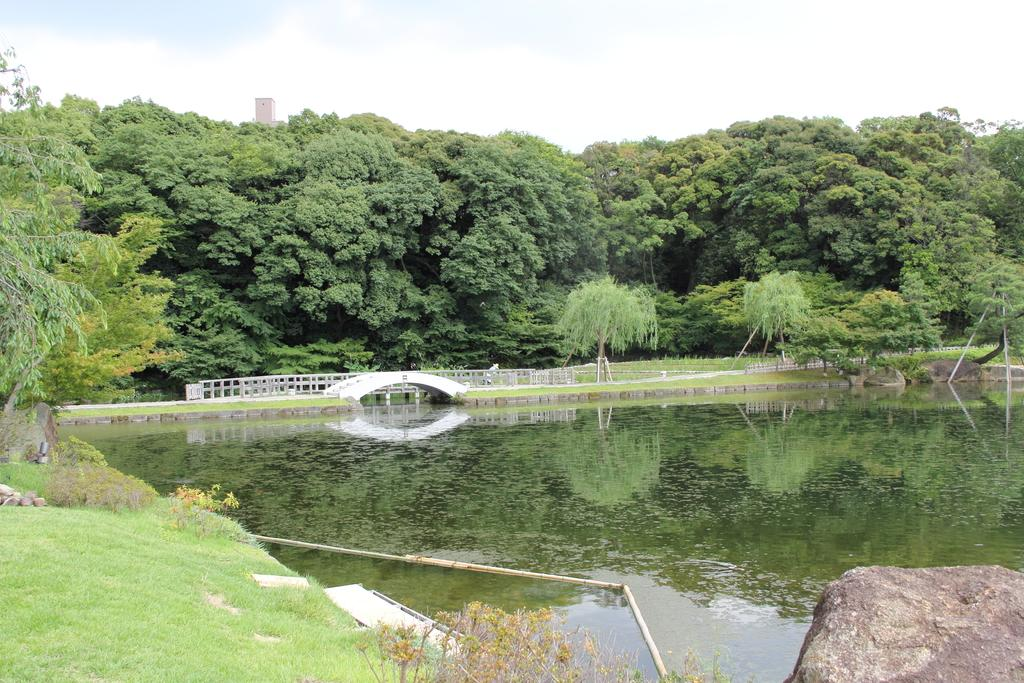What body of water is present in the image? There is a lake in the image. What structure can be seen on the lake? There is a bridge on the lake. What type of vegetation surrounds the lake? The lake is surrounded by trees. What can be seen in the background of the image? The sky is visible in the background of the image. How much money is floating on the surface of the lake in the image? There is no money visible on the surface of the lake in the image. 